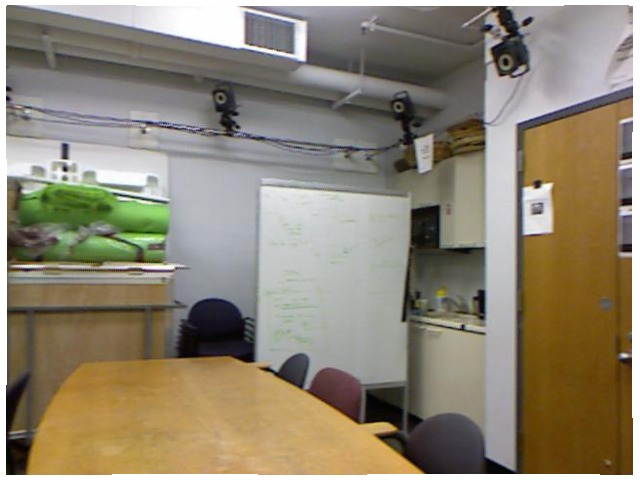<image>
Is the chair in front of the chair? No. The chair is not in front of the chair. The spatial positioning shows a different relationship between these objects. Is the speaker on the wall? No. The speaker is not positioned on the wall. They may be near each other, but the speaker is not supported by or resting on top of the wall. Where is the table in relation to the chair? Is it on the chair? No. The table is not positioned on the chair. They may be near each other, but the table is not supported by or resting on top of the chair. 